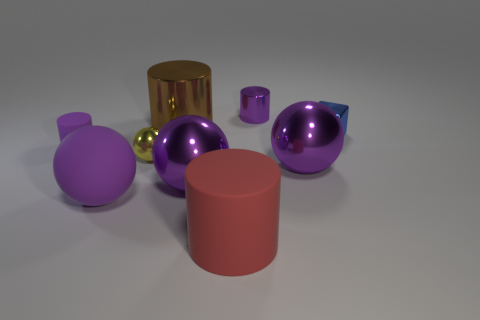How many purple things have the same size as the purple rubber cylinder?
Ensure brevity in your answer.  1. There is a purple cylinder that is right of the small rubber cylinder; what number of small things are left of it?
Your answer should be compact. 2. Is the large purple ball on the right side of the big rubber cylinder made of the same material as the big red cylinder?
Your answer should be compact. No. Does the large object that is behind the small metal cube have the same material as the big cylinder in front of the tiny purple rubber cylinder?
Your answer should be very brief. No. Are there more small purple metal things that are left of the small blue thing than yellow matte cylinders?
Ensure brevity in your answer.  Yes. There is a big metal sphere to the right of the tiny metallic object behind the small shiny cube; what color is it?
Make the answer very short. Purple. The purple rubber object that is the same size as the brown shiny object is what shape?
Your answer should be compact. Sphere. What shape is the tiny rubber object that is the same color as the small shiny cylinder?
Provide a short and direct response. Cylinder. Is the number of brown metallic cylinders that are to the right of the big red object the same as the number of small yellow matte spheres?
Make the answer very short. Yes. What material is the small purple object that is on the left side of the metal ball to the left of the big cylinder that is to the left of the red matte cylinder?
Offer a terse response. Rubber. 